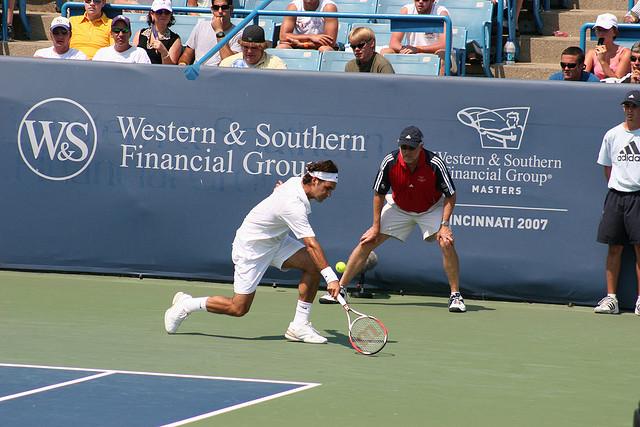What is he holding?
Keep it brief. Tennis racket. Which tennis tournament is this?
Be succinct. Masters. What sport is this?
Answer briefly. Tennis. 